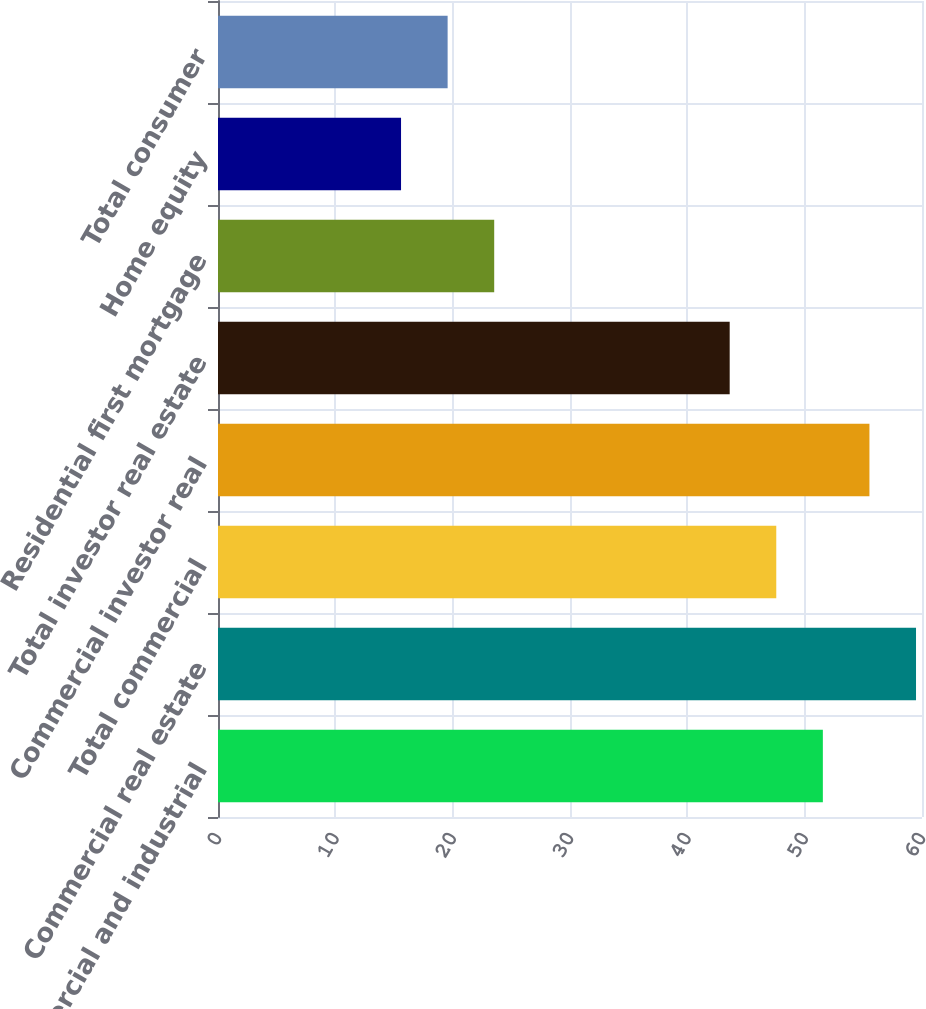<chart> <loc_0><loc_0><loc_500><loc_500><bar_chart><fcel>Commercial and industrial<fcel>Commercial real estate<fcel>Total commercial<fcel>Commercial investor real<fcel>Total investor real estate<fcel>Residential first mortgage<fcel>Home equity<fcel>Total consumer<nl><fcel>51.55<fcel>59.49<fcel>47.58<fcel>55.52<fcel>43.61<fcel>23.54<fcel>15.6<fcel>19.57<nl></chart> 